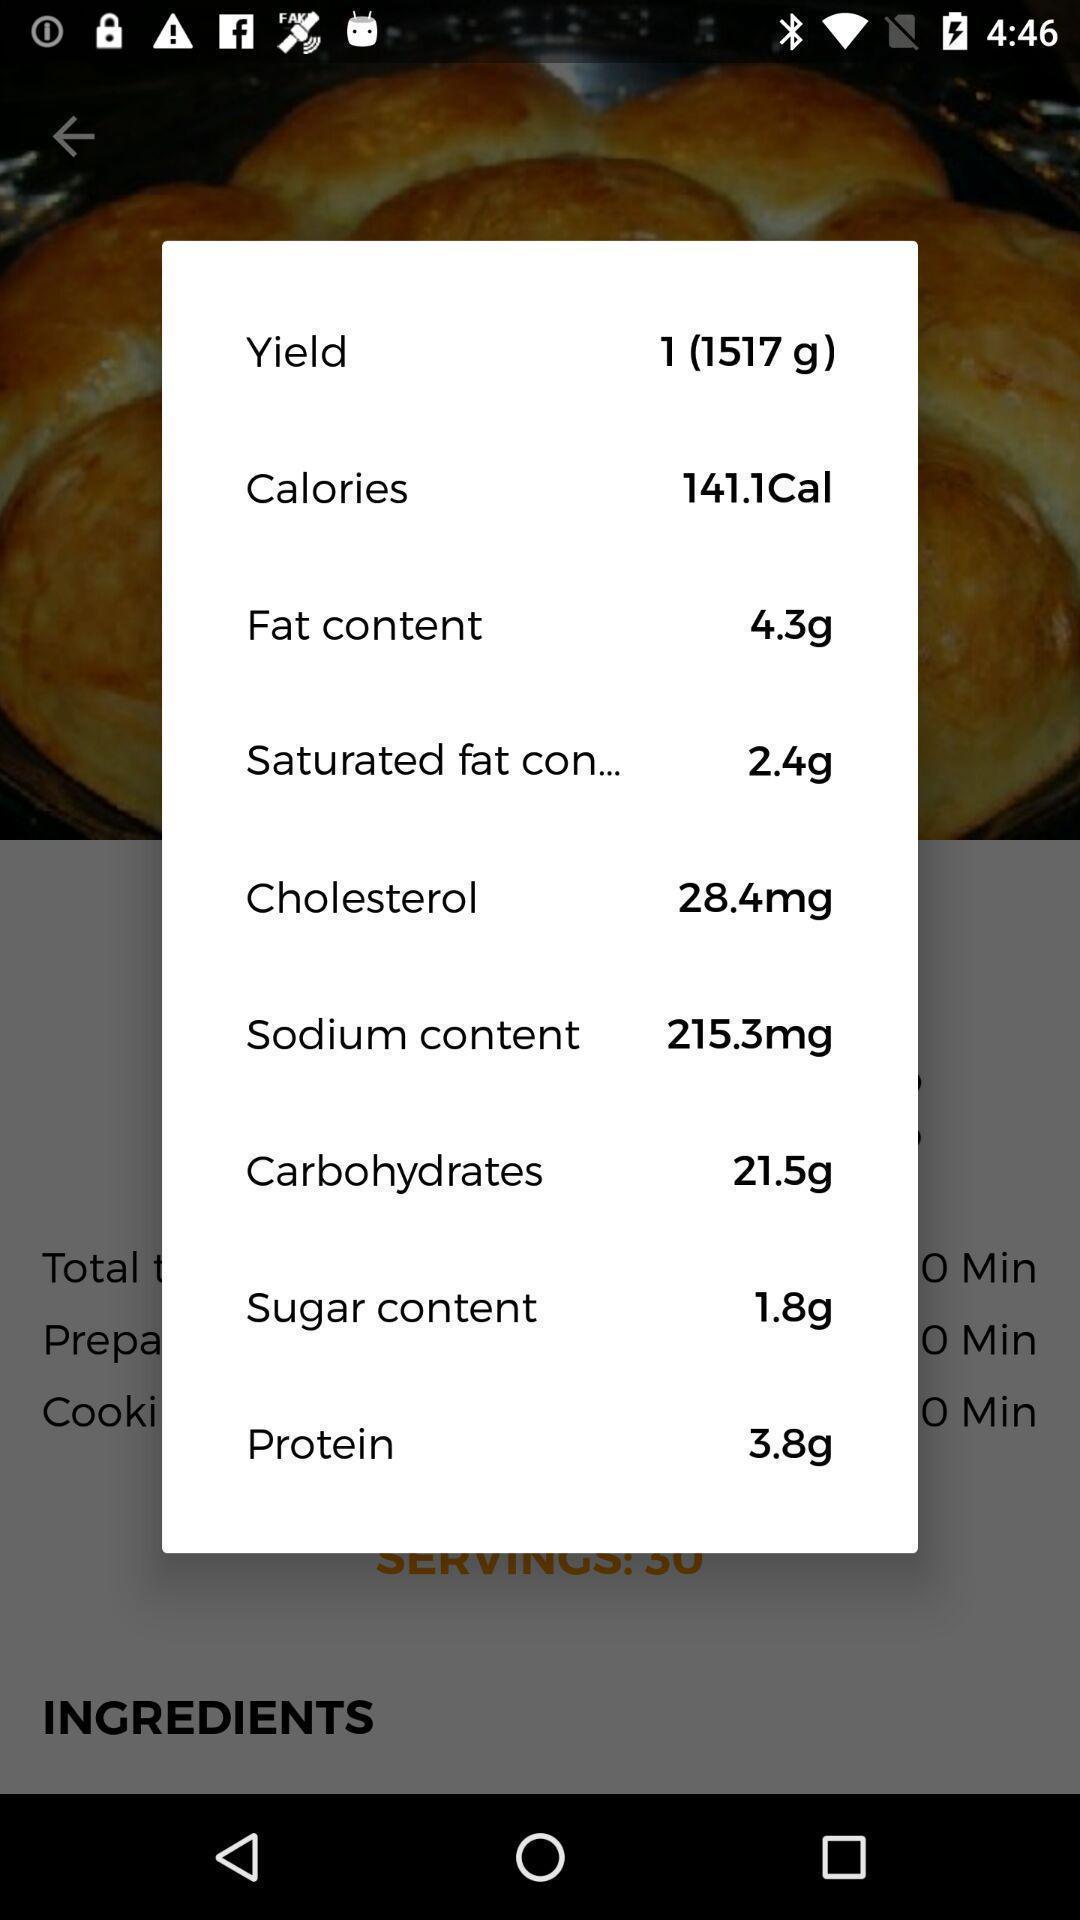Give me a narrative description of this picture. Pop up screen of informative details of recipe. 